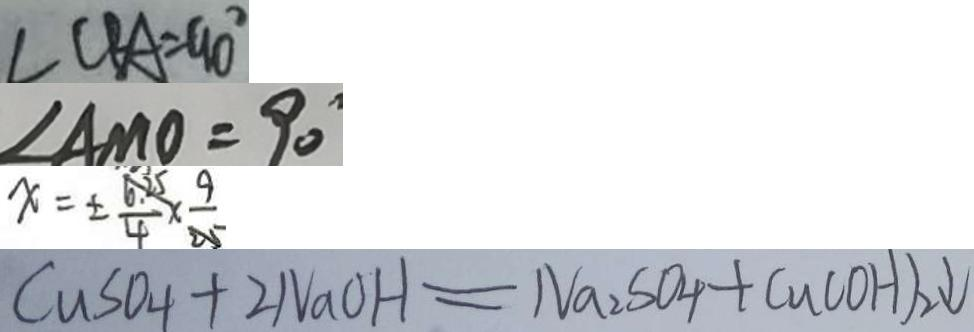<formula> <loc_0><loc_0><loc_500><loc_500>\angle C B A = 9 0 ^ { \circ } 
 \angle A M O = 9 0 ^ { \circ } 
 x = \pm \frac { 6 . 2 5 } { 4 } \times \frac { 9 } { 2 5 } 
 C u S O _ { 4 } + 2 N a O H = N a _ { 2 } S O _ { 4 } + C u ( O H ) _ { 2 } \downarrow</formula> 